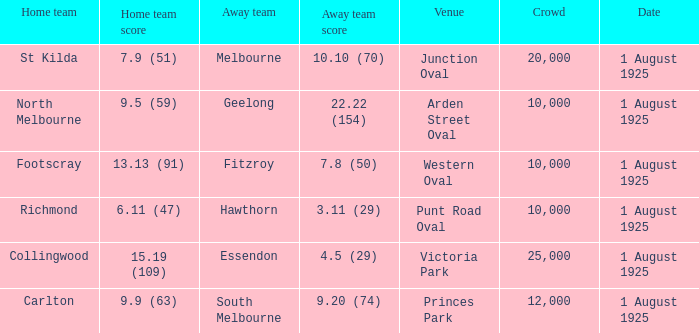What was the away team's score at the match played at The Western Oval? 7.8 (50). 